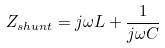<formula> <loc_0><loc_0><loc_500><loc_500>Z _ { s h u n t } = j \omega L + { \frac { 1 } { j \omega C } }</formula> 